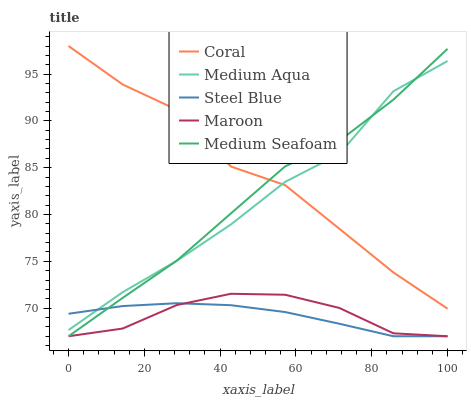Does Steel Blue have the minimum area under the curve?
Answer yes or no. Yes. Does Coral have the maximum area under the curve?
Answer yes or no. Yes. Does Medium Aqua have the minimum area under the curve?
Answer yes or no. No. Does Medium Aqua have the maximum area under the curve?
Answer yes or no. No. Is Steel Blue the smoothest?
Answer yes or no. Yes. Is Coral the roughest?
Answer yes or no. Yes. Is Medium Aqua the smoothest?
Answer yes or no. No. Is Medium Aqua the roughest?
Answer yes or no. No. Does Steel Blue have the lowest value?
Answer yes or no. Yes. Does Medium Aqua have the lowest value?
Answer yes or no. No. Does Coral have the highest value?
Answer yes or no. Yes. Does Medium Aqua have the highest value?
Answer yes or no. No. Is Maroon less than Medium Aqua?
Answer yes or no. Yes. Is Medium Aqua greater than Maroon?
Answer yes or no. Yes. Does Medium Aqua intersect Steel Blue?
Answer yes or no. Yes. Is Medium Aqua less than Steel Blue?
Answer yes or no. No. Is Medium Aqua greater than Steel Blue?
Answer yes or no. No. Does Maroon intersect Medium Aqua?
Answer yes or no. No. 